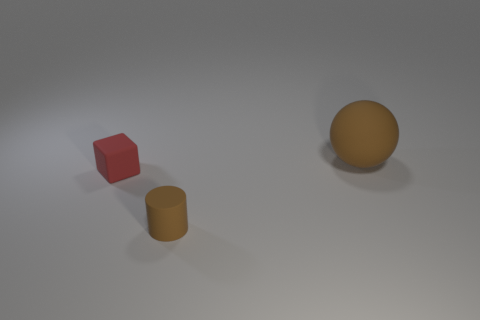What number of objects are tiny red objects or matte things to the left of the large brown rubber thing?
Give a very brief answer. 2. Do the brown matte thing that is in front of the brown sphere and the tiny object behind the tiny brown cylinder have the same shape?
Offer a very short reply. No. How many things are either large cyan matte things or matte cubes?
Your answer should be very brief. 1. Is there any other thing that has the same material as the big sphere?
Provide a succinct answer. Yes. Are any brown matte spheres visible?
Keep it short and to the point. Yes. Do the brown thing on the left side of the large brown ball and the cube have the same material?
Your answer should be compact. Yes. Is there a big yellow thing that has the same shape as the red thing?
Provide a short and direct response. No. Is the number of blocks in front of the large rubber object the same as the number of large brown balls?
Provide a succinct answer. Yes. What is the material of the brown object that is in front of the brown thing that is on the right side of the tiny cylinder?
Provide a succinct answer. Rubber. The red rubber thing is what shape?
Provide a succinct answer. Cube. 